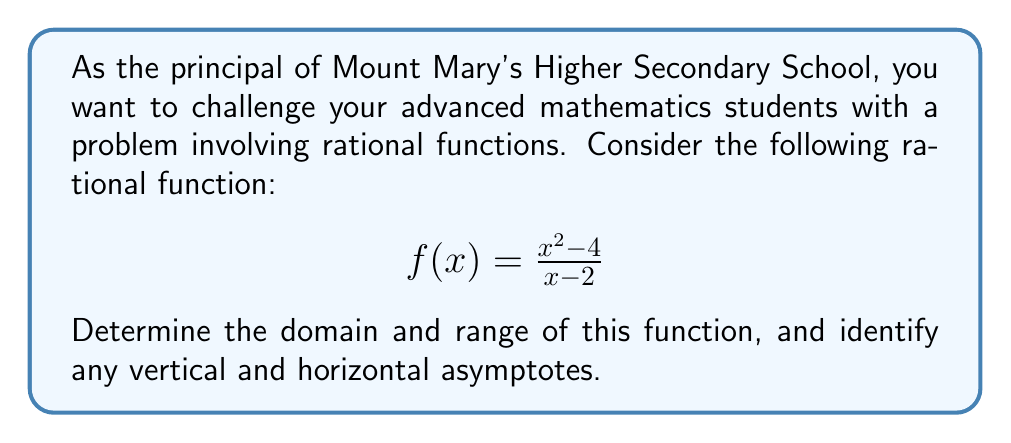Help me with this question. Let's approach this step-by-step:

1) Domain:
   The domain of a rational function includes all real numbers except those that make the denominator zero.
   Set the denominator equal to zero and solve:
   $x - 2 = 0$
   $x = 2$
   Therefore, the domain is all real numbers except 2, or $\{x \in \mathbb{R} | x \neq 2\}$.

2) Vertical Asymptote:
   The vertical asymptote occurs where the denominator equals zero, which we found is at $x = 2$.

3) Horizontal Asymptote:
   To find the horizontal asymptote, we compare the degrees of the numerator and denominator:
   - Degree of numerator: 2
   - Degree of denominator: 1
   Since the degree of the numerator is greater than the degree of the denominator, there is no horizontal asymptote. The function will approach positive or negative infinity as $x$ approaches infinity.

4) Simplification:
   We can factor the numerator:
   $$f(x) = \frac{(x+2)(x-2)}{x-2}$$
   The $(x-2)$ terms cancel out, leaving us with:
   $$f(x) = x + 2$$ for $x \neq 2$

5) Range:
   After simplification, we can see that $f(x)$ is a linear function for all $x \neq 2$. It can take on any real value except when $x = 2$. The function approaches positive and negative infinity as $x$ approaches positive and negative infinity.
   Therefore, the range is all real numbers, or $\mathbb{R}$.
Answer: Domain: $\{x \in \mathbb{R} | x \neq 2\}$
Range: $\mathbb{R}$
Vertical asymptote: $x = 2$
Horizontal asymptote: None 